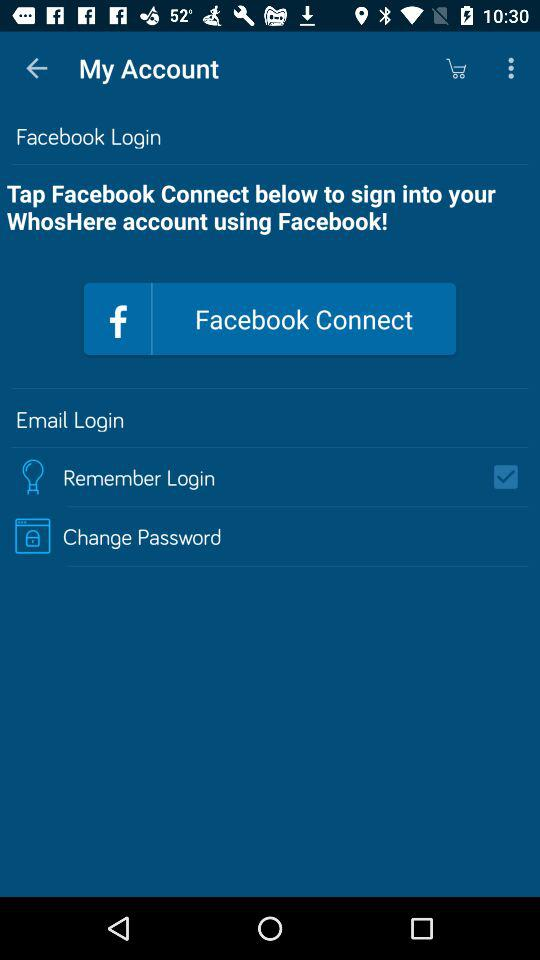What's the status of "Remember Login"? The status is on. 